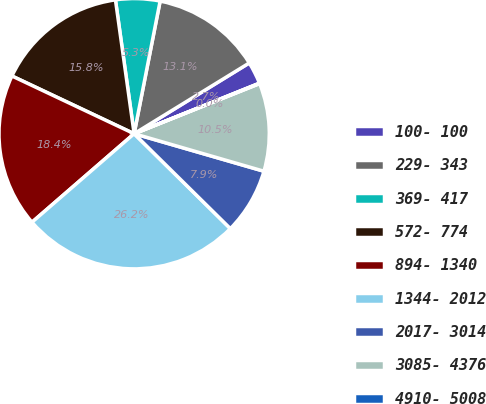<chart> <loc_0><loc_0><loc_500><loc_500><pie_chart><fcel>100- 100<fcel>229- 343<fcel>369- 417<fcel>572- 774<fcel>894- 1340<fcel>1344- 2012<fcel>2017- 3014<fcel>3085- 4376<fcel>4910- 5008<nl><fcel>2.67%<fcel>13.15%<fcel>5.29%<fcel>15.77%<fcel>18.39%<fcel>26.25%<fcel>7.91%<fcel>10.53%<fcel>0.05%<nl></chart> 